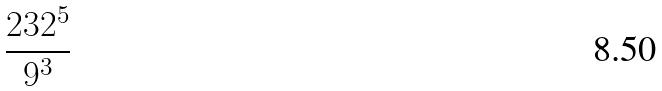<formula> <loc_0><loc_0><loc_500><loc_500>\frac { 2 3 2 ^ { 5 } } { 9 ^ { 3 } }</formula> 